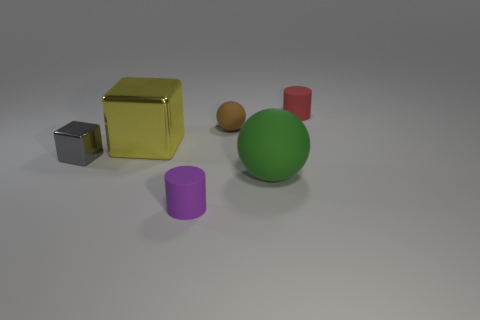Add 3 large purple matte cubes. How many objects exist? 9 Subtract 1 cylinders. How many cylinders are left? 1 Subtract all balls. How many objects are left? 4 Subtract all yellow cylinders. Subtract all small gray things. How many objects are left? 5 Add 5 metallic blocks. How many metallic blocks are left? 7 Add 2 brown matte objects. How many brown matte objects exist? 3 Subtract 0 green blocks. How many objects are left? 6 Subtract all green cylinders. Subtract all blue cubes. How many cylinders are left? 2 